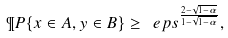Convert formula to latex. <formula><loc_0><loc_0><loc_500><loc_500>\P P \{ x \in A , y \in B \} \geq \ e p s ^ { \frac { 2 - \sqrt { 1 - \alpha } } { 1 - \sqrt { 1 - \alpha } } } ,</formula> 